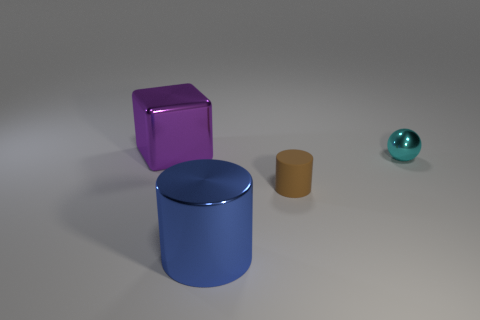Add 4 blue cylinders. How many objects exist? 8 Subtract all spheres. How many objects are left? 3 Subtract 1 cylinders. How many cylinders are left? 1 Add 3 big cubes. How many big cubes exist? 4 Subtract 0 red balls. How many objects are left? 4 Subtract all cyan cylinders. Subtract all red balls. How many cylinders are left? 2 Subtract all big blue things. Subtract all large purple metal blocks. How many objects are left? 2 Add 1 small rubber things. How many small rubber things are left? 2 